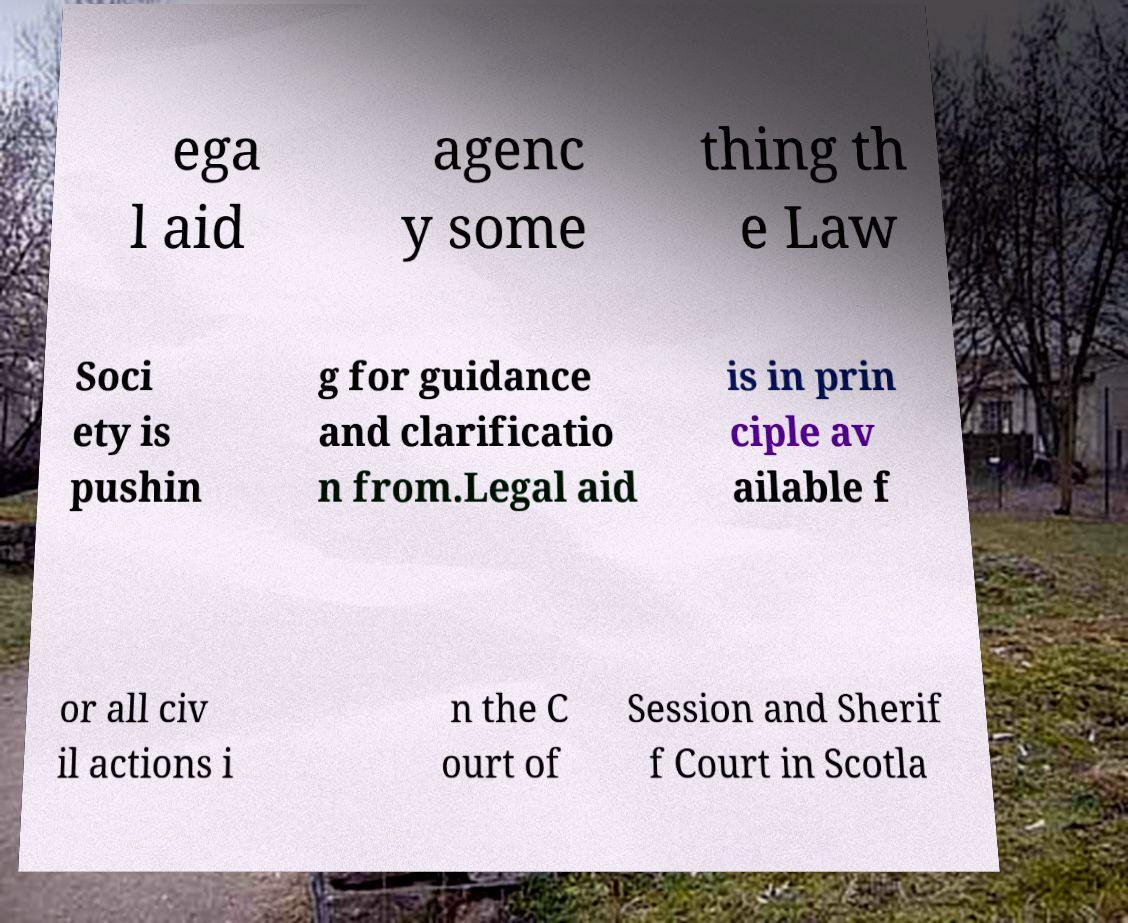Could you assist in decoding the text presented in this image and type it out clearly? ega l aid agenc y some thing th e Law Soci ety is pushin g for guidance and clarificatio n from.Legal aid is in prin ciple av ailable f or all civ il actions i n the C ourt of Session and Sherif f Court in Scotla 